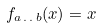<formula> <loc_0><loc_0><loc_500><loc_500>f _ { a \, . \, . \, b } ( x ) = x</formula> 